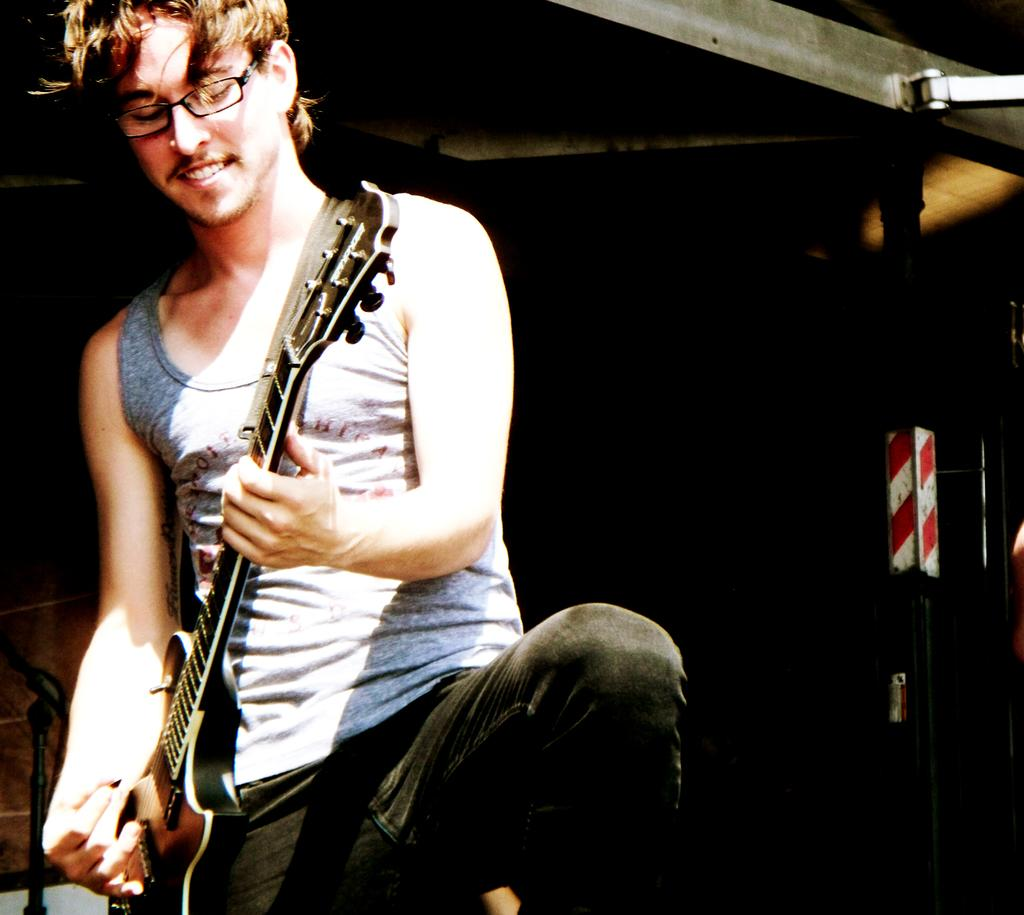What is the man in the image doing? The man is playing a guitar in the image. What accessory is the man wearing in the image? The man is wearing spectacles in the image. What expression does the man have in the image? The man is smiling in the image. What is the title of the artwork in the image? There is no information about the title of the artwork in the image, as it is not mentioned in the provided facts. 